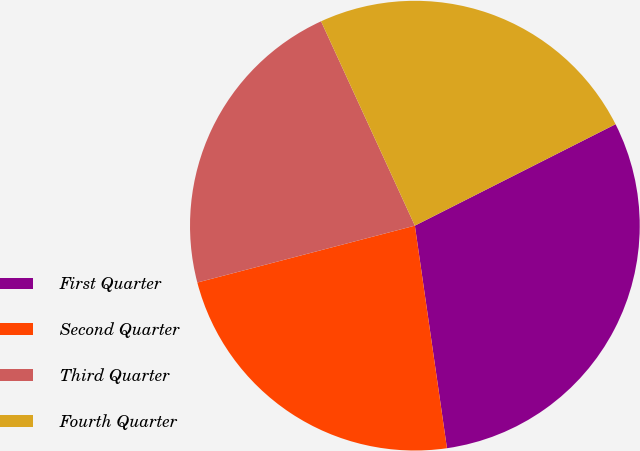Convert chart. <chart><loc_0><loc_0><loc_500><loc_500><pie_chart><fcel>First Quarter<fcel>Second Quarter<fcel>Third Quarter<fcel>Fourth Quarter<nl><fcel>30.17%<fcel>23.21%<fcel>22.22%<fcel>24.4%<nl></chart> 